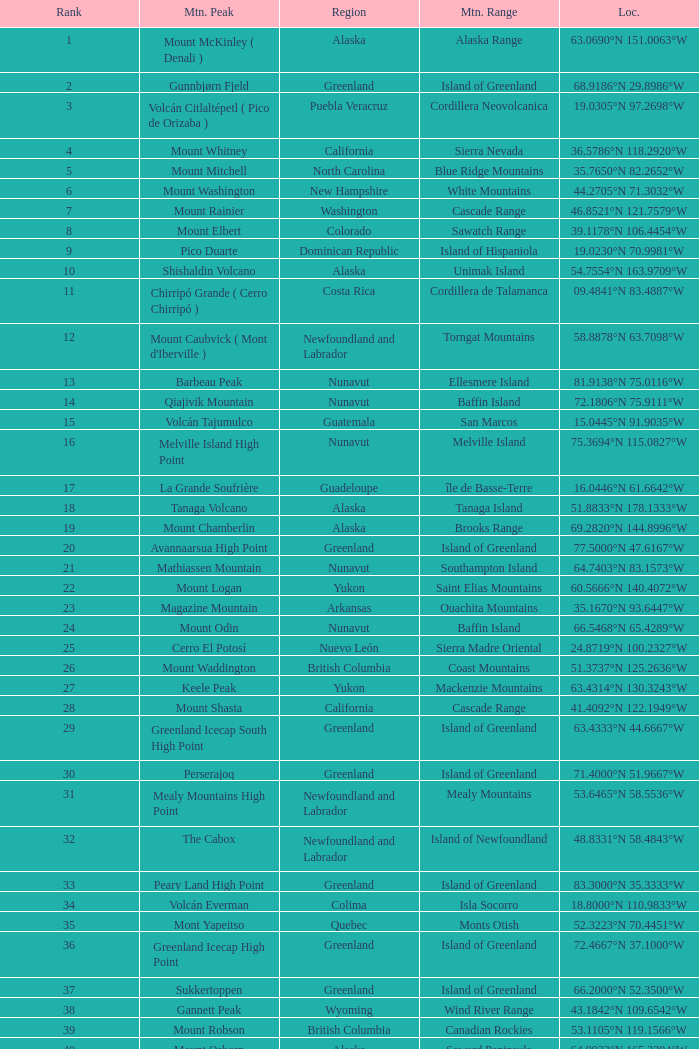Which Mountain Range has a Region of haiti, and a Location of 18.3601°n 71.9764°w? Island of Hispaniola. 